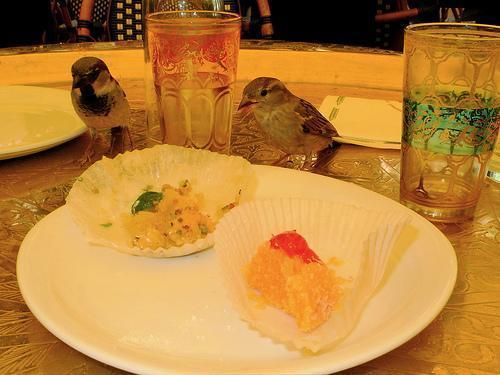How many glasses are there?
Give a very brief answer. 2. 